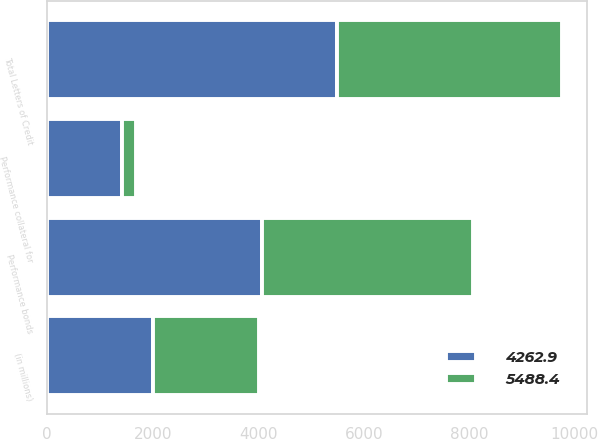Convert chart. <chart><loc_0><loc_0><loc_500><loc_500><stacked_bar_chart><ecel><fcel>(in millions)<fcel>Performance bonds<fcel>Performance collateral for<fcel>Total Letters of Credit<nl><fcel>4262.9<fcel>2010<fcel>4071.8<fcel>1416.6<fcel>5488.4<nl><fcel>5488.4<fcel>2009<fcel>4000.9<fcel>262<fcel>4262.9<nl></chart> 